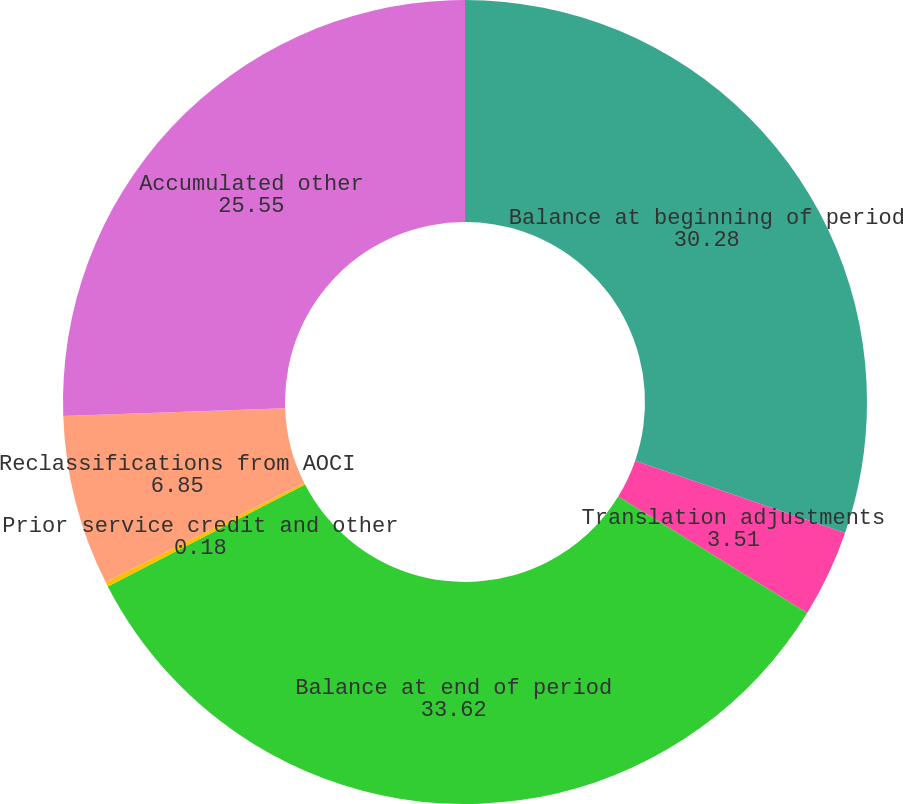Convert chart. <chart><loc_0><loc_0><loc_500><loc_500><pie_chart><fcel>Balance at beginning of period<fcel>Translation adjustments<fcel>Balance at end of period<fcel>Prior service credit and other<fcel>Reclassifications from AOCI<fcel>Accumulated other<nl><fcel>30.28%<fcel>3.51%<fcel>33.62%<fcel>0.18%<fcel>6.85%<fcel>25.55%<nl></chart> 